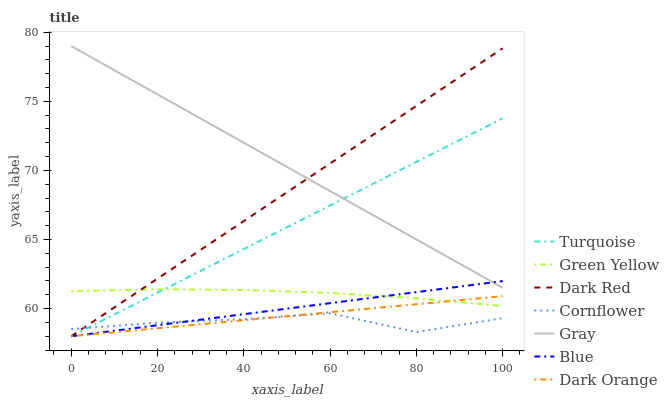Does Cornflower have the minimum area under the curve?
Answer yes or no. Yes. Does Gray have the maximum area under the curve?
Answer yes or no. Yes. Does Turquoise have the minimum area under the curve?
Answer yes or no. No. Does Turquoise have the maximum area under the curve?
Answer yes or no. No. Is Blue the smoothest?
Answer yes or no. Yes. Is Cornflower the roughest?
Answer yes or no. Yes. Is Gray the smoothest?
Answer yes or no. No. Is Gray the roughest?
Answer yes or no. No. Does Blue have the lowest value?
Answer yes or no. Yes. Does Gray have the lowest value?
Answer yes or no. No. Does Gray have the highest value?
Answer yes or no. Yes. Does Turquoise have the highest value?
Answer yes or no. No. Is Dark Orange less than Gray?
Answer yes or no. Yes. Is Gray greater than Dark Orange?
Answer yes or no. Yes. Does Blue intersect Dark Orange?
Answer yes or no. Yes. Is Blue less than Dark Orange?
Answer yes or no. No. Is Blue greater than Dark Orange?
Answer yes or no. No. Does Dark Orange intersect Gray?
Answer yes or no. No. 